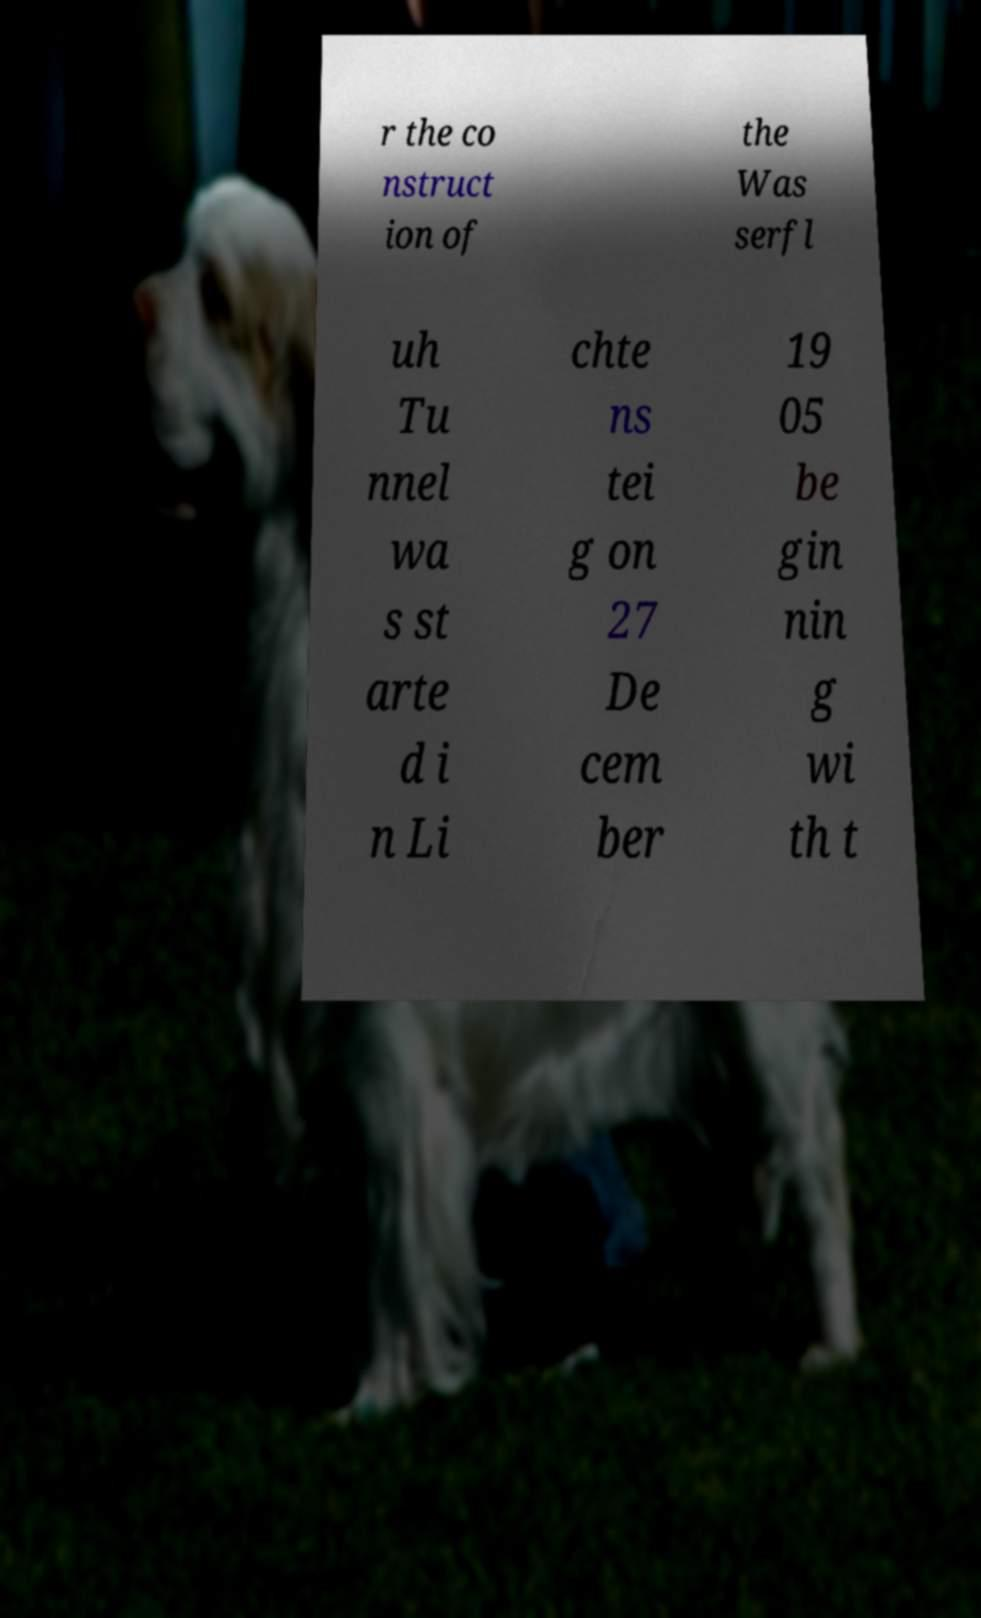Could you extract and type out the text from this image? r the co nstruct ion of the Was serfl uh Tu nnel wa s st arte d i n Li chte ns tei g on 27 De cem ber 19 05 be gin nin g wi th t 